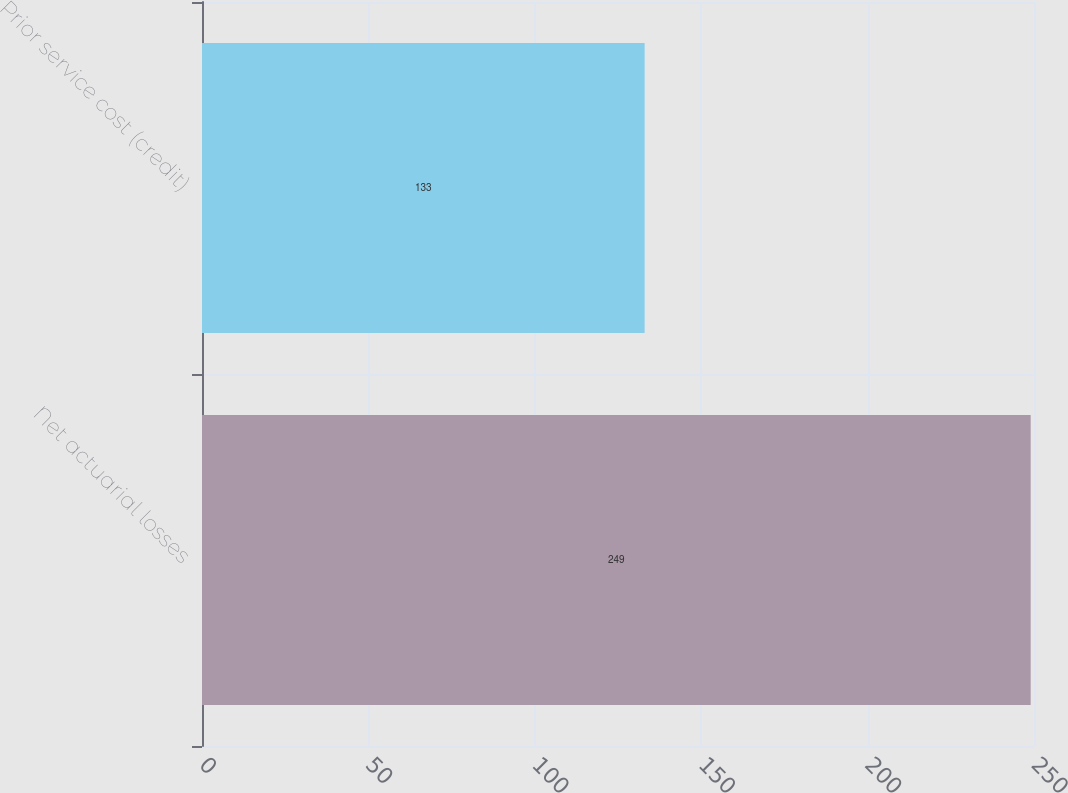Convert chart. <chart><loc_0><loc_0><loc_500><loc_500><bar_chart><fcel>Net actuarial losses<fcel>Prior service cost (credit)<nl><fcel>249<fcel>133<nl></chart> 